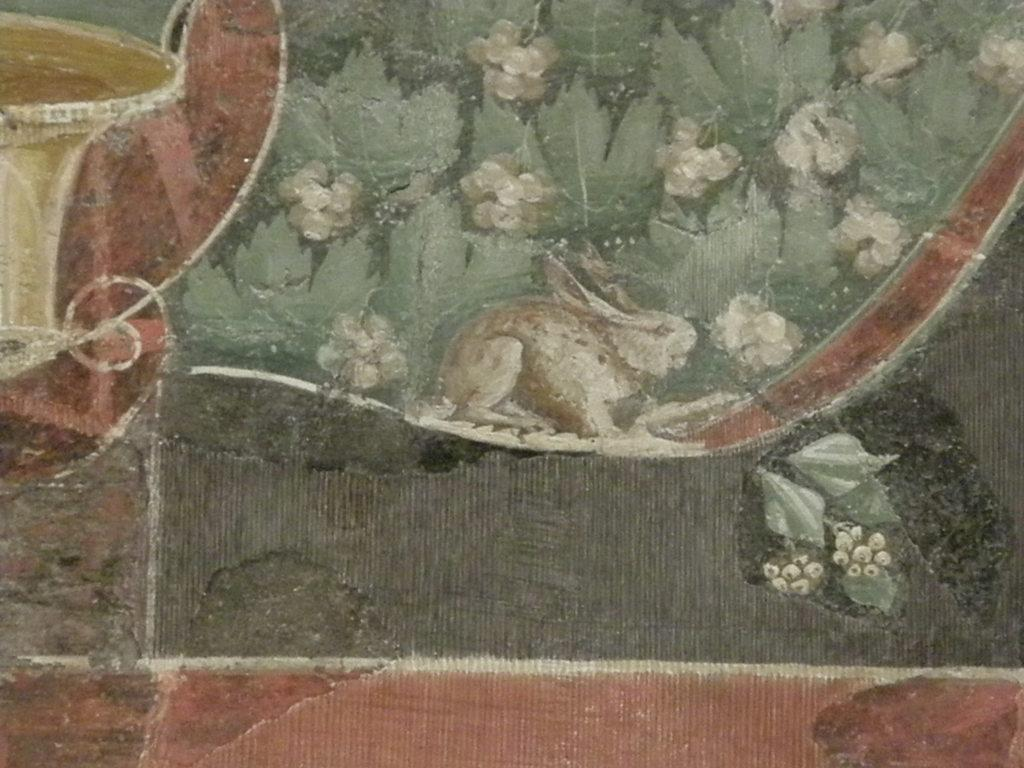What is located in the center of the image? There is a wall in the center of the image. What is on the wall? There is a painting on the wall. What is depicted in the painting? The painting contains a rabbit, plants, and flowers. Are there any other elements in the painting? Yes, there are other objects present in the painting. What type of jam is being spread on the doll's hair in the image? There is no doll or jam present in the image; the painting only features a rabbit, plants, and flowers. 